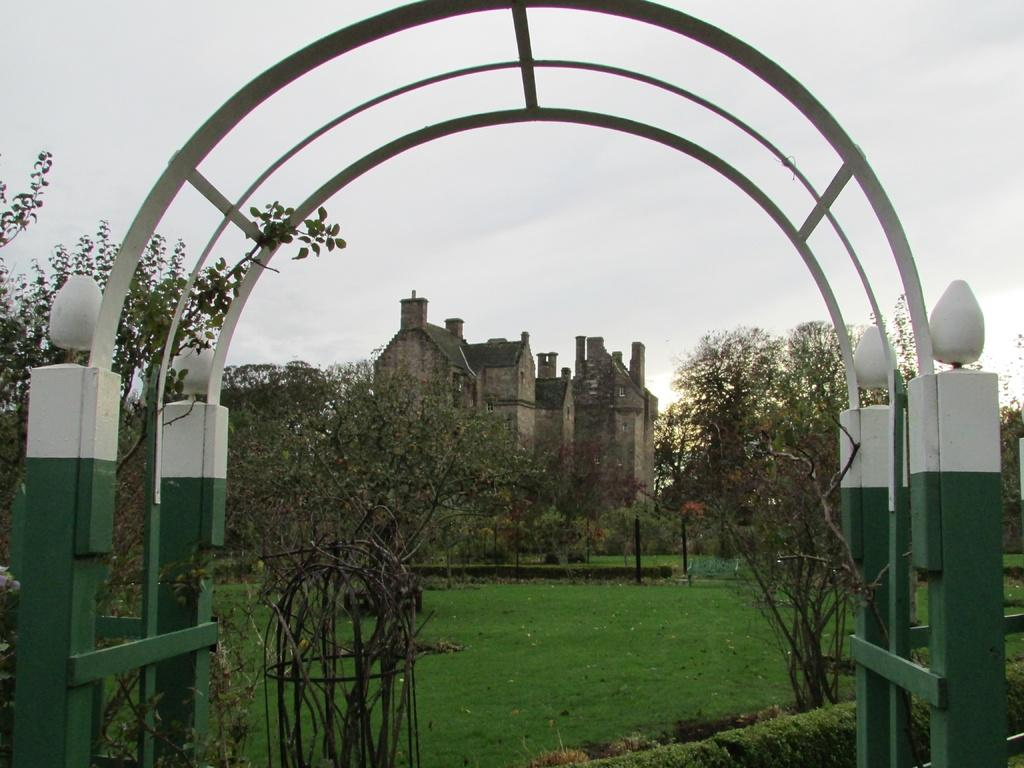What is the main structure visible in the image? There is a white and green color arch in the image. What can be seen behind the arch? There is a garden behind the arch. What type of building is visible in the background of the image? There is an old castle house visible in the background of the image. What type of fear can be seen on the faces of the people in the image? There are no people visible in the image, so it is not possible to determine their emotions or fears. 